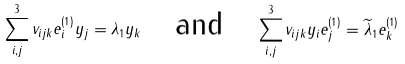Convert formula to latex. <formula><loc_0><loc_0><loc_500><loc_500>\sum _ { i , j } ^ { 3 } v _ { i j k } e ^ { ( 1 ) } _ { i } y _ { j } = \lambda _ { 1 } y _ { k } \quad \text {and} \quad \sum _ { i , j } ^ { 3 } v _ { i j k } y _ { i } e _ { j } ^ { ( 1 ) } = \widetilde { \lambda } _ { 1 } e ^ { ( 1 ) } _ { k }</formula> 